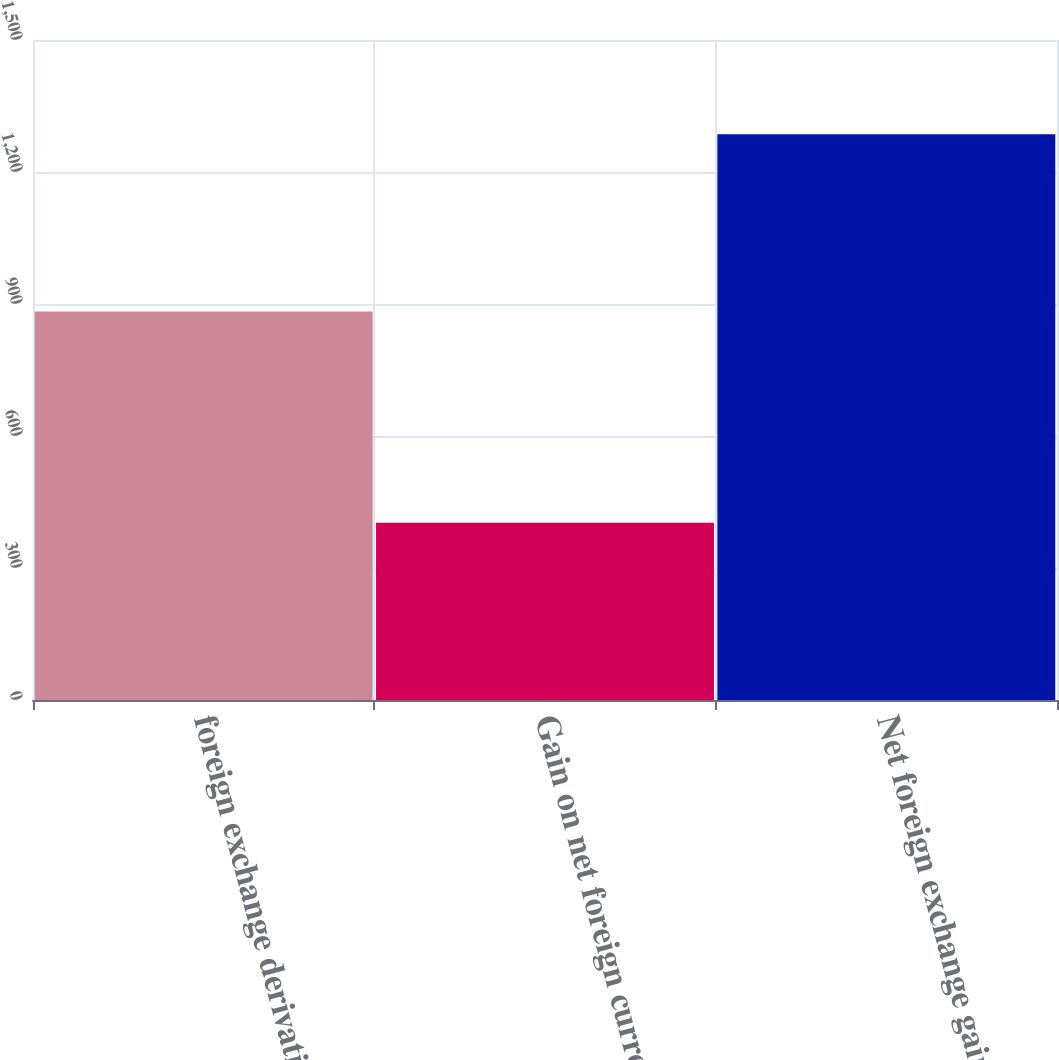Convert chart. <chart><loc_0><loc_0><loc_500><loc_500><bar_chart><fcel>foreign exchange derivatives<fcel>Gain on net foreign currency<fcel>Net foreign exchange gain<nl><fcel>883<fcel>403<fcel>1286<nl></chart> 